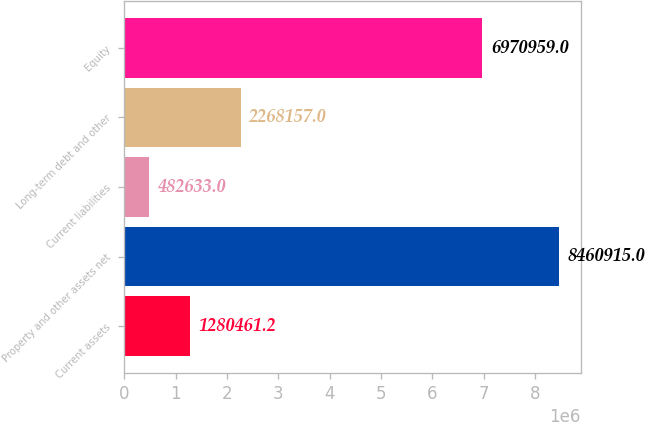Convert chart. <chart><loc_0><loc_0><loc_500><loc_500><bar_chart><fcel>Current assets<fcel>Property and other assets net<fcel>Current liabilities<fcel>Long-term debt and other<fcel>Equity<nl><fcel>1.28046e+06<fcel>8.46092e+06<fcel>482633<fcel>2.26816e+06<fcel>6.97096e+06<nl></chart> 